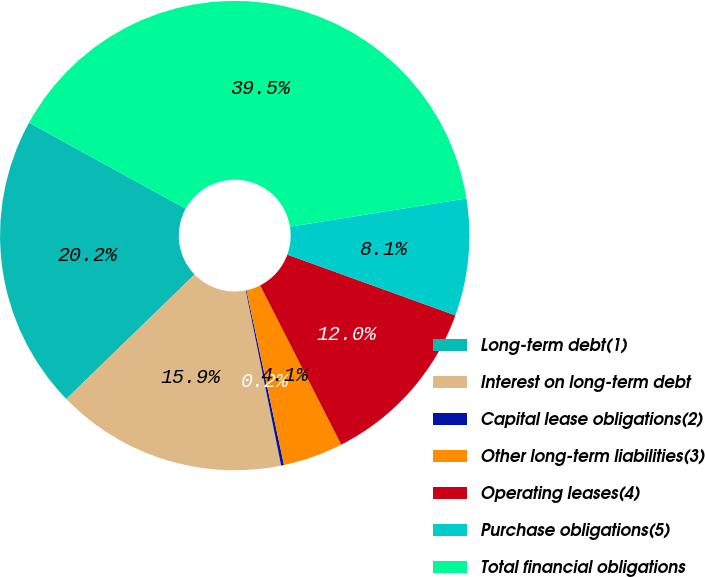Convert chart. <chart><loc_0><loc_0><loc_500><loc_500><pie_chart><fcel>Long-term debt(1)<fcel>Interest on long-term debt<fcel>Capital lease obligations(2)<fcel>Other long-term liabilities(3)<fcel>Operating leases(4)<fcel>Purchase obligations(5)<fcel>Total financial obligations<nl><fcel>20.25%<fcel>15.91%<fcel>0.2%<fcel>4.13%<fcel>11.98%<fcel>8.05%<fcel>39.48%<nl></chart> 